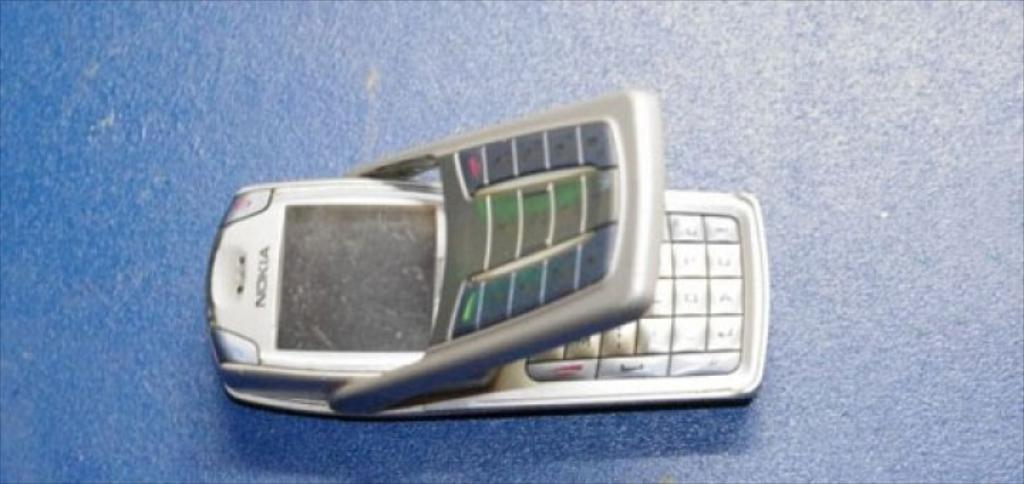<image>
Present a compact description of the photo's key features. A Nokia cellphone with two layers of keyboard. 